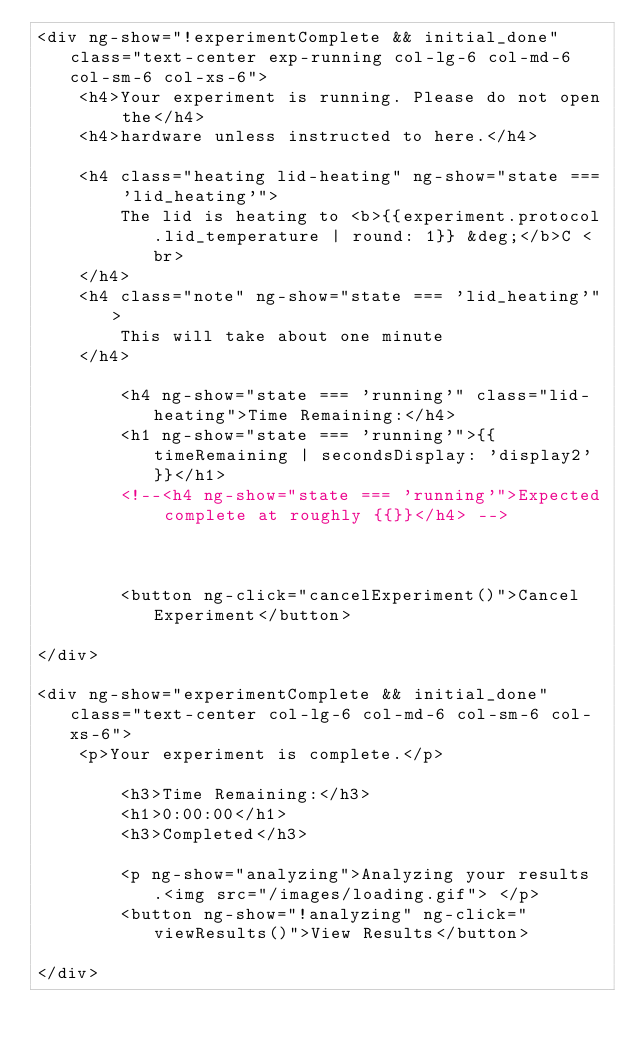<code> <loc_0><loc_0><loc_500><loc_500><_HTML_><div ng-show="!experimentComplete && initial_done" class="text-center exp-running col-lg-6 col-md-6 col-sm-6 col-xs-6">
	<h4>Your experiment is running. Please do not open the</h4>
	<h4>hardware unless instructed to here.</h4>

	<h4 class="heating lid-heating" ng-show="state === 'lid_heating'">
		The lid is heating to <b>{{experiment.protocol.lid_temperature | round: 1}} &deg;</b>C <br>
	</h4>
	<h4 class="note" ng-show="state === 'lid_heating'">
		This will take about one minute
	</h4>

		<h4 ng-show="state === 'running'" class="lid-heating">Time Remaining:</h4>
		<h1 ng-show="state === 'running'">{{ timeRemaining | secondsDisplay: 'display2'}}</h1>
		<!--<h4 ng-show="state === 'running'">Expected complete at roughly {{}}</h4> -->



		<button ng-click="cancelExperiment()">Cancel Experiment</button>

</div>

<div ng-show="experimentComplete && initial_done" class="text-center col-lg-6 col-md-6 col-sm-6 col-xs-6">
	<p>Your experiment is complete.</p>

		<h3>Time Remaining:</h3>
		<h1>0:00:00</h1>
		<h3>Completed</h3>

		<p ng-show="analyzing">Analyzing your results.<img src="/images/loading.gif"> </p>
		<button ng-show="!analyzing" ng-click="viewResults()">View Results</button>

</div>
</code> 